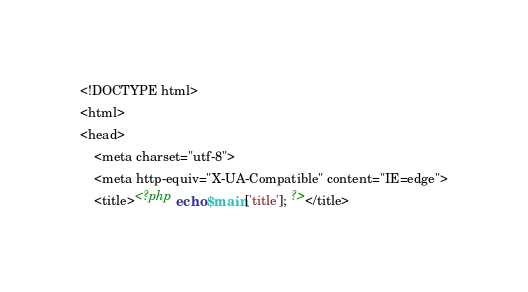Convert code to text. <code><loc_0><loc_0><loc_500><loc_500><_PHP_><!DOCTYPE html>
<html>
<head>
	<meta charset="utf-8"> 
	<meta http-equiv="X-UA-Compatible" content="IE=edge">
	<title><?php echo $main['title']; ?></title></code> 